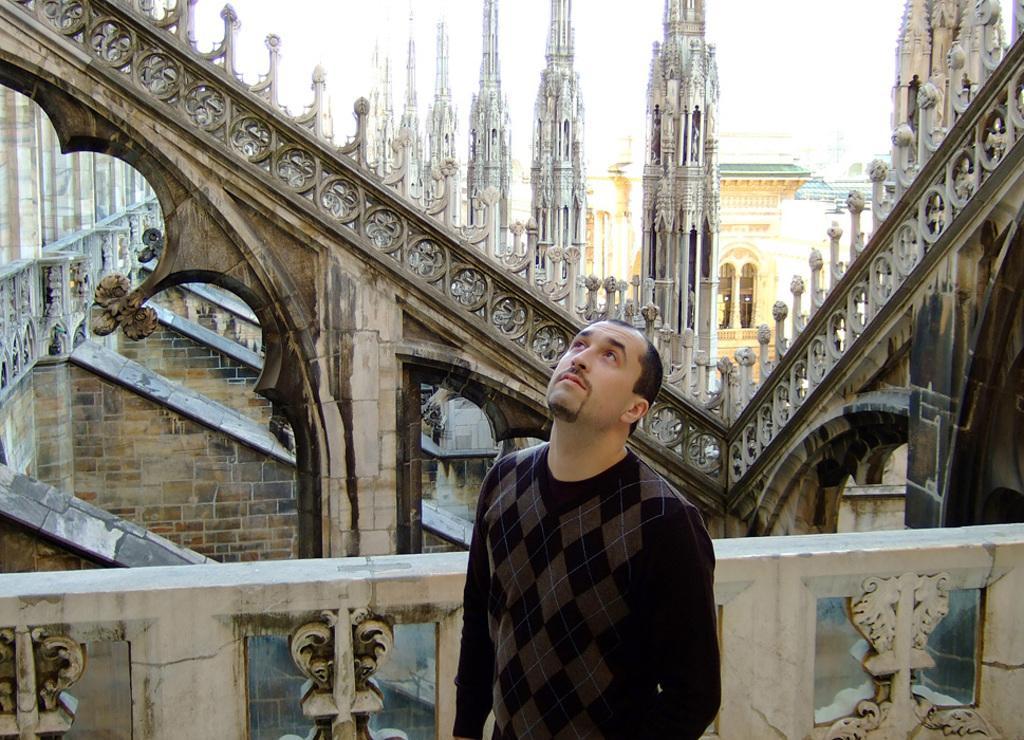Please provide a concise description of this image. In the center of the image, we can see a person standing and in the background, there are buildings and we can see a railing. 